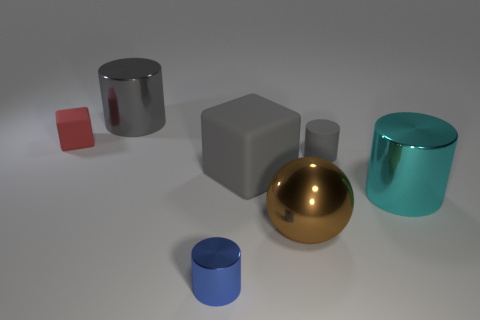Add 3 small green metallic cubes. How many objects exist? 10 Subtract all green cylinders. Subtract all red cubes. How many cylinders are left? 4 Subtract all blocks. How many objects are left? 5 Add 4 cylinders. How many cylinders are left? 8 Add 5 small red matte cubes. How many small red matte cubes exist? 6 Subtract 1 brown balls. How many objects are left? 6 Subtract all red metallic cylinders. Subtract all large gray rubber objects. How many objects are left? 6 